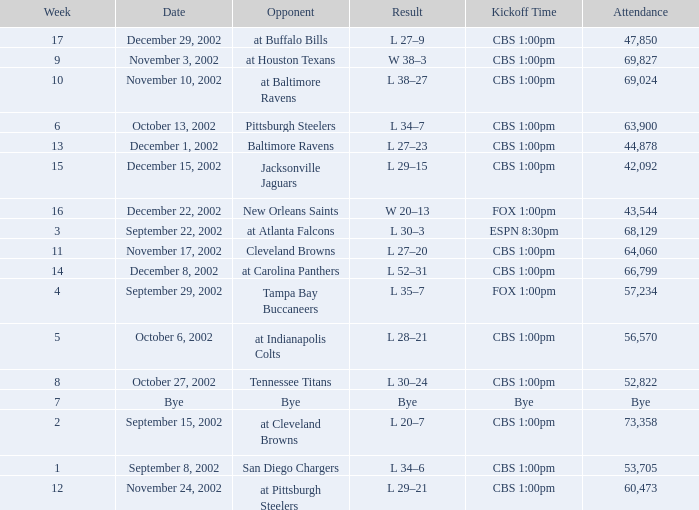What week number was the kickoff time cbs 1:00pm, with 60,473 people in attendance? 1.0. 